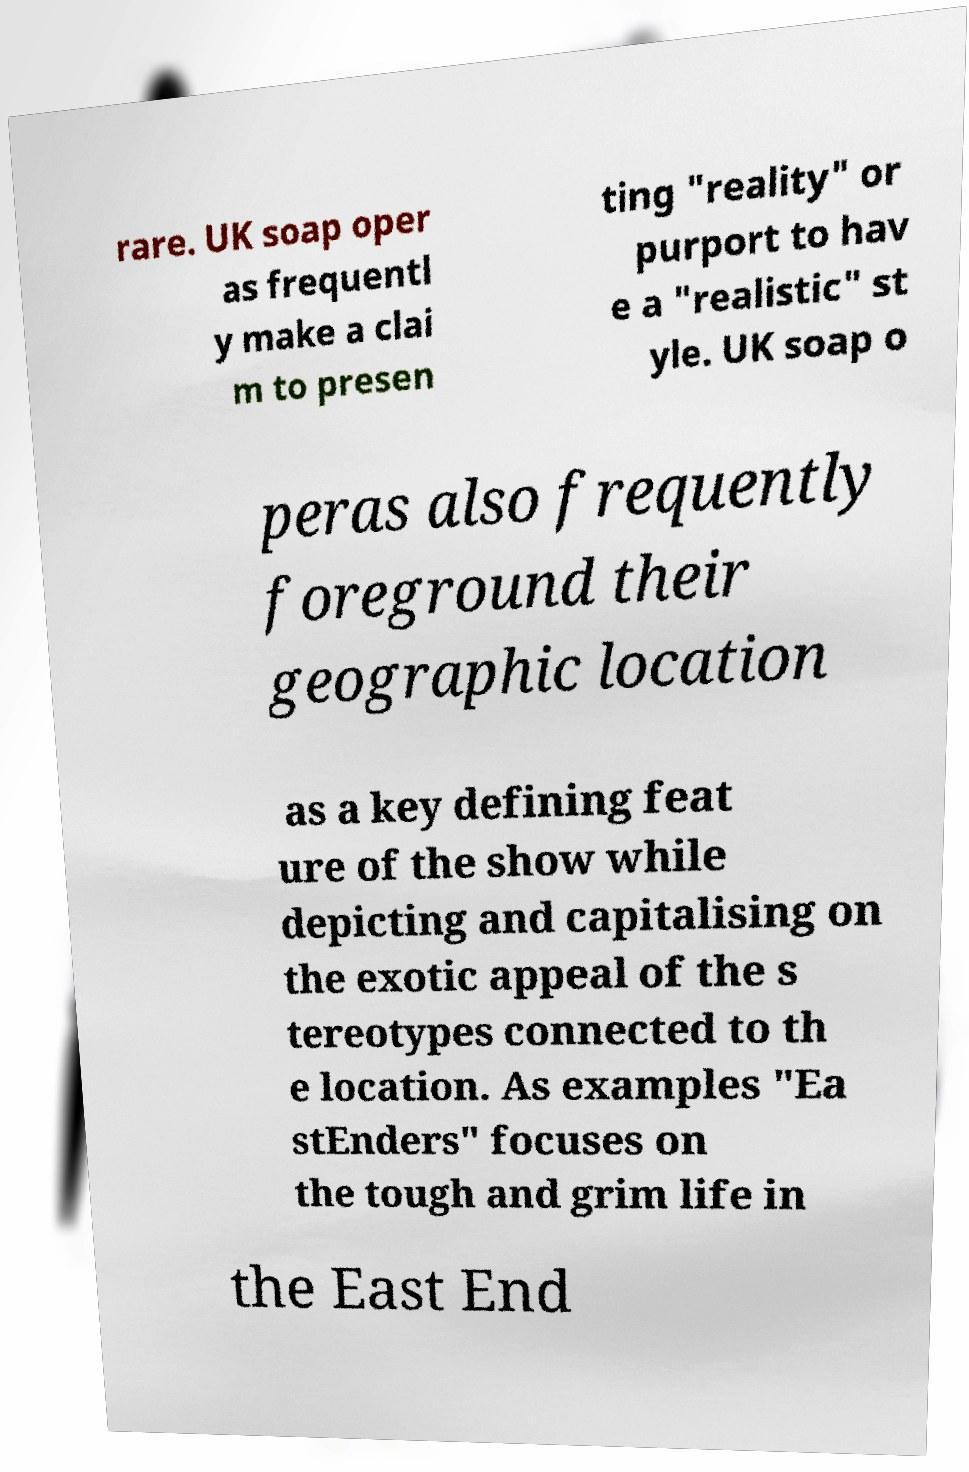Could you assist in decoding the text presented in this image and type it out clearly? rare. UK soap oper as frequentl y make a clai m to presen ting "reality" or purport to hav e a "realistic" st yle. UK soap o peras also frequently foreground their geographic location as a key defining feat ure of the show while depicting and capitalising on the exotic appeal of the s tereotypes connected to th e location. As examples "Ea stEnders" focuses on the tough and grim life in the East End 